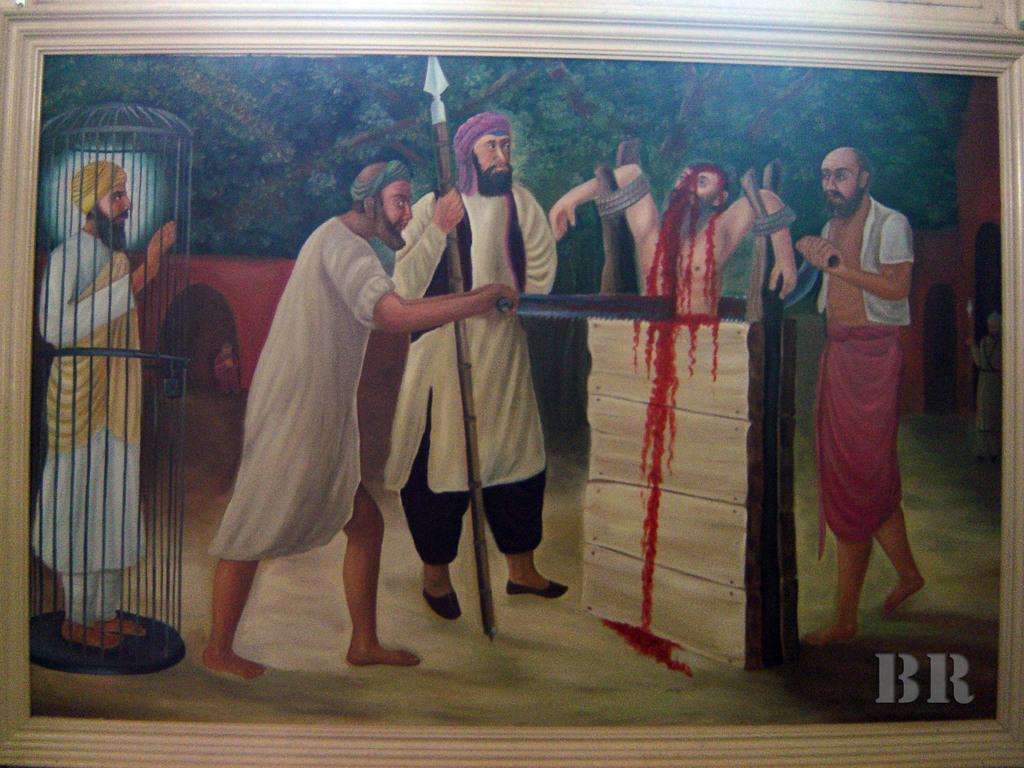How would you summarize this image in a sentence or two? In this image, we can see a painting with frame. Here we can see few people. 